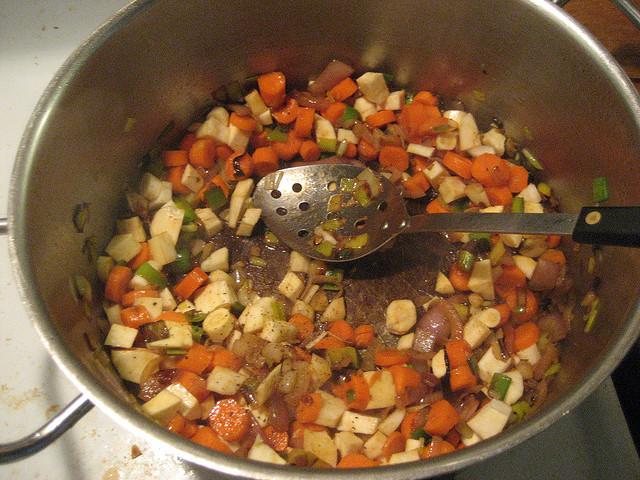What is frying in the pan?
Give a very brief answer. Vegetables. Is the soup boiling?
Be succinct. No. What type of kitchen tool is in the pot?
Keep it brief. Spoon. What type of dish is this?
Be succinct. Stew. What is the orange food in the pot?
Short answer required. Carrots. What material is the spoon made from?
Be succinct. Metal. What is everything cooking in?
Give a very brief answer. Pot. 